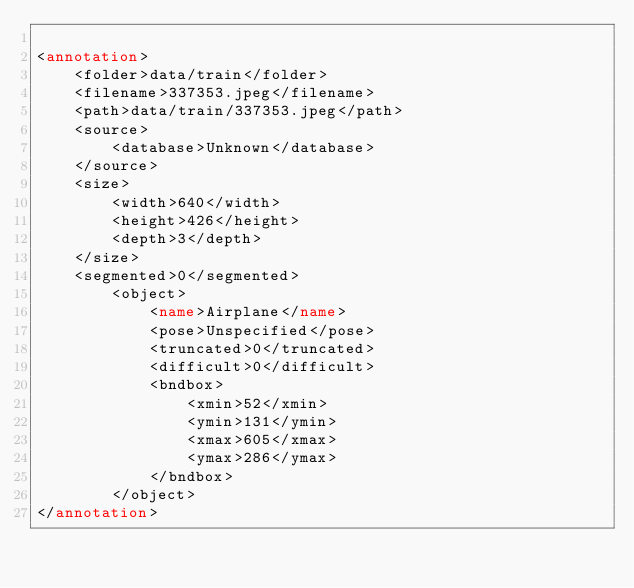<code> <loc_0><loc_0><loc_500><loc_500><_XML_>
<annotation>
    <folder>data/train</folder>
    <filename>337353.jpeg</filename>
    <path>data/train/337353.jpeg</path>
    <source>
        <database>Unknown</database>
    </source>
    <size>
        <width>640</width>
        <height>426</height>
        <depth>3</depth>
    </size>
    <segmented>0</segmented>
        <object>
            <name>Airplane</name>
            <pose>Unspecified</pose>
            <truncated>0</truncated>
            <difficult>0</difficult>
            <bndbox>
                <xmin>52</xmin>
                <ymin>131</ymin>
                <xmax>605</xmax>
                <ymax>286</ymax>
            </bndbox>
        </object>
</annotation>
</code> 